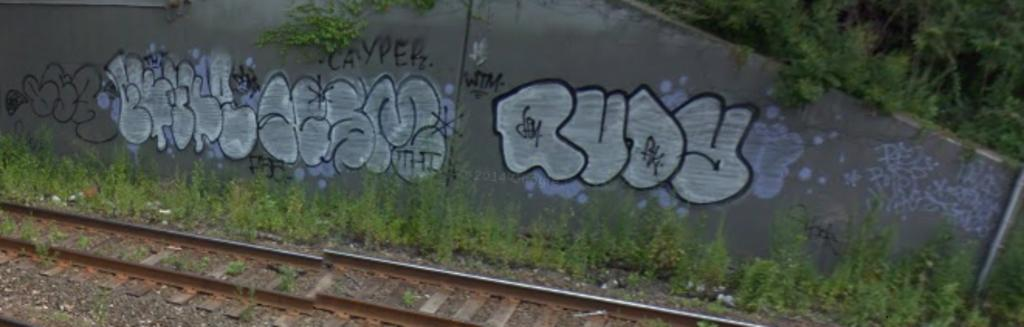<image>
Relay a brief, clear account of the picture shown. A dilapidated train track with graffiti on the walls that says Rudy. 